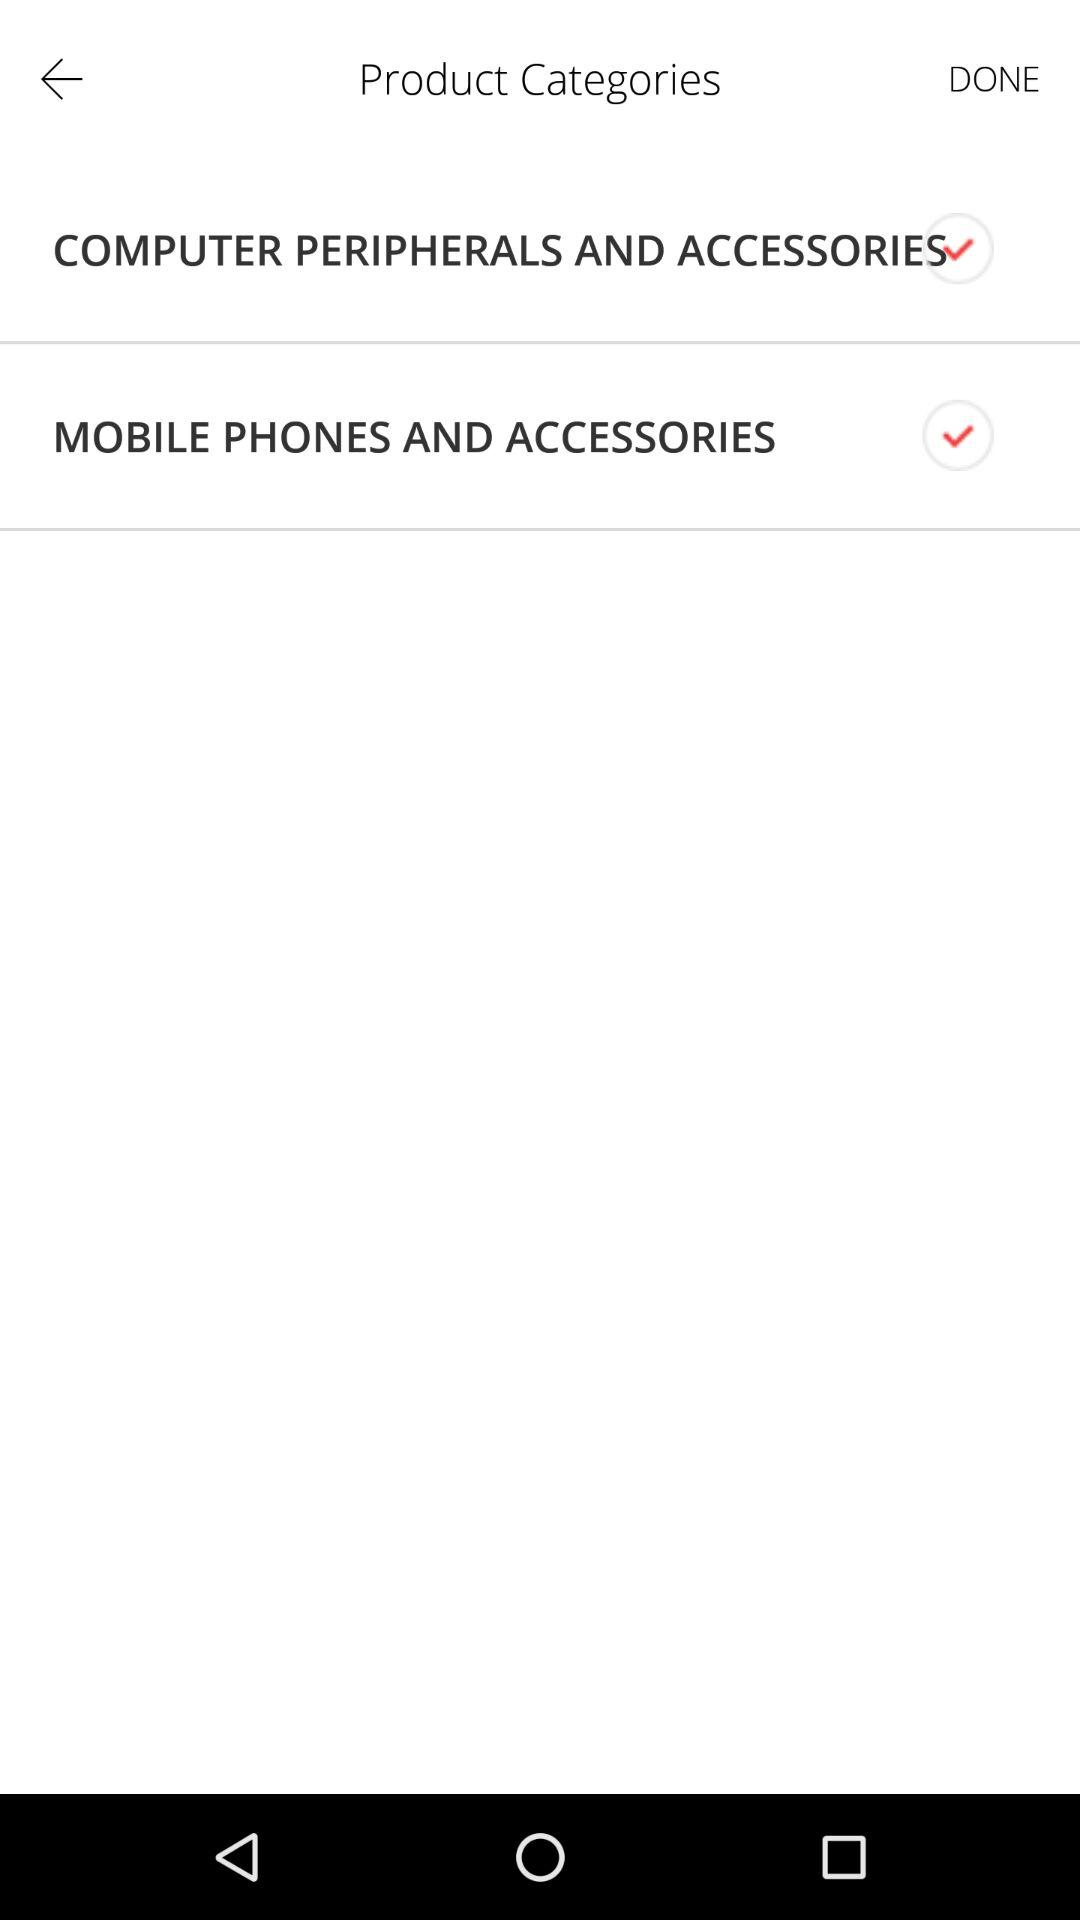What is the status of "COMPUTER PERIPHERALS AND ACCESSORIES"? The status is "on". 